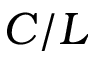Convert formula to latex. <formula><loc_0><loc_0><loc_500><loc_500>C / L</formula> 